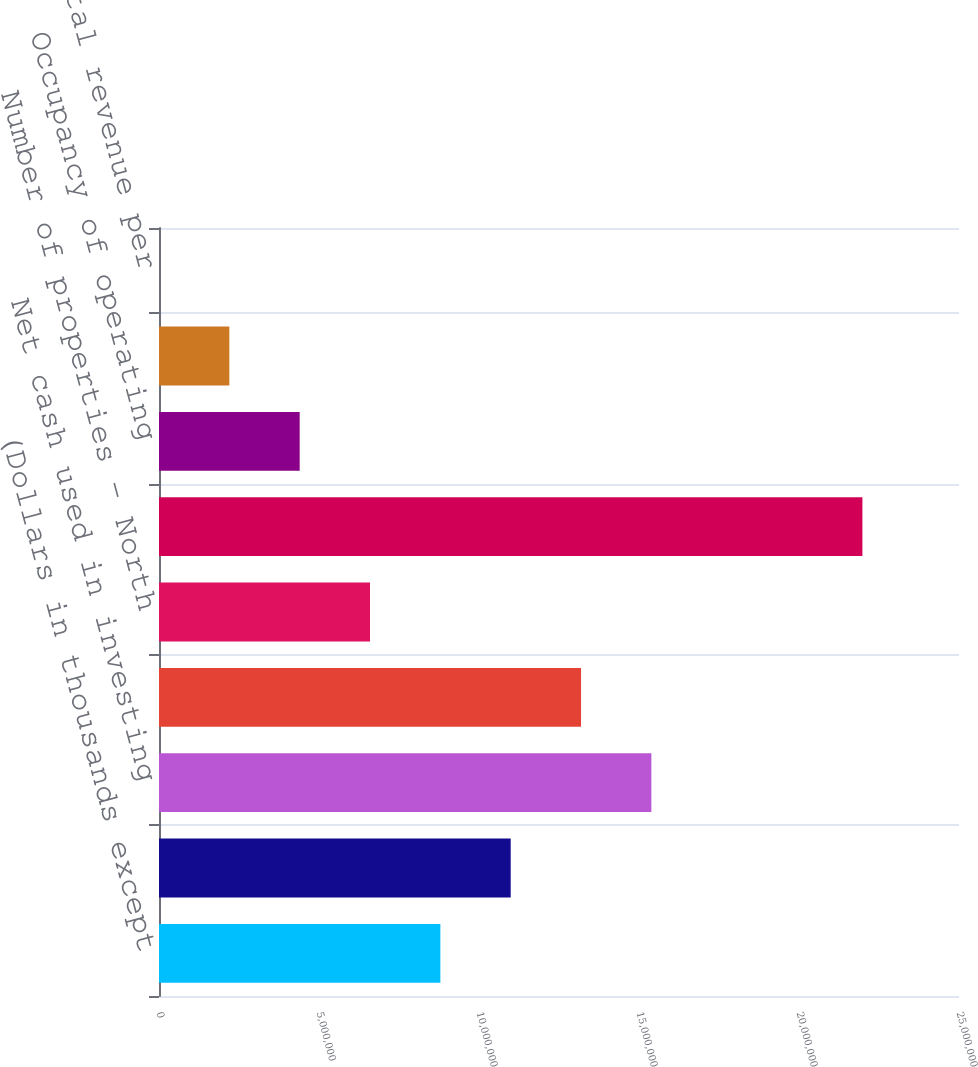<chart> <loc_0><loc_0><loc_500><loc_500><bar_chart><fcel>(Dollars in thousands except<fcel>Net cash provided by operating<fcel>Net cash used in investing<fcel>Net cash provided by financing<fcel>Number of properties - North<fcel>RSF (including development and<fcel>Occupancy of operating<fcel>Occupancy of operating and<fcel>Annual rental revenue per<nl><fcel>8.79248e+06<fcel>1.09906e+07<fcel>1.53868e+07<fcel>1.31887e+07<fcel>6.59437e+06<fcel>2.19811e+07<fcel>4.39627e+06<fcel>2.19816e+06<fcel>48.01<nl></chart> 